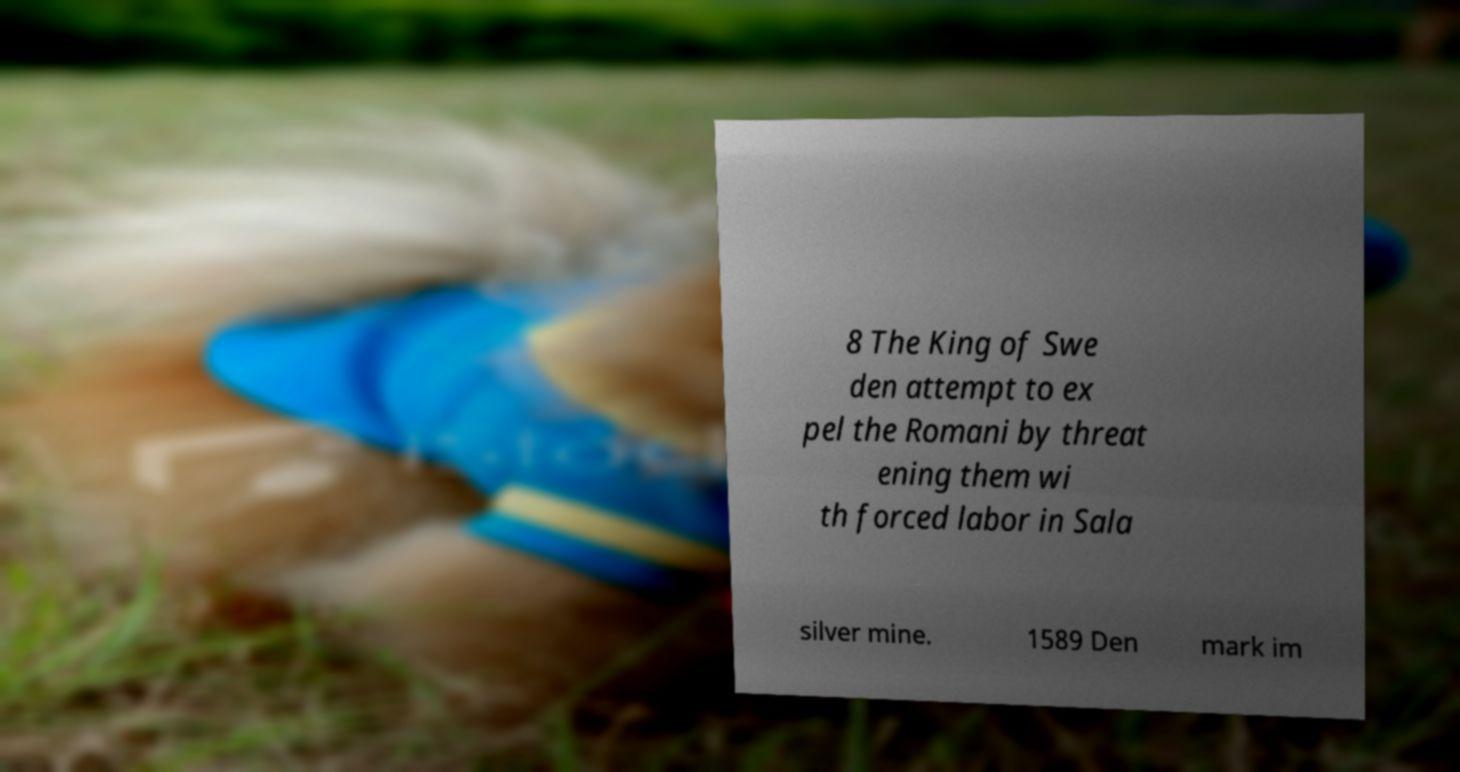Please identify and transcribe the text found in this image. 8 The King of Swe den attempt to ex pel the Romani by threat ening them wi th forced labor in Sala silver mine. 1589 Den mark im 